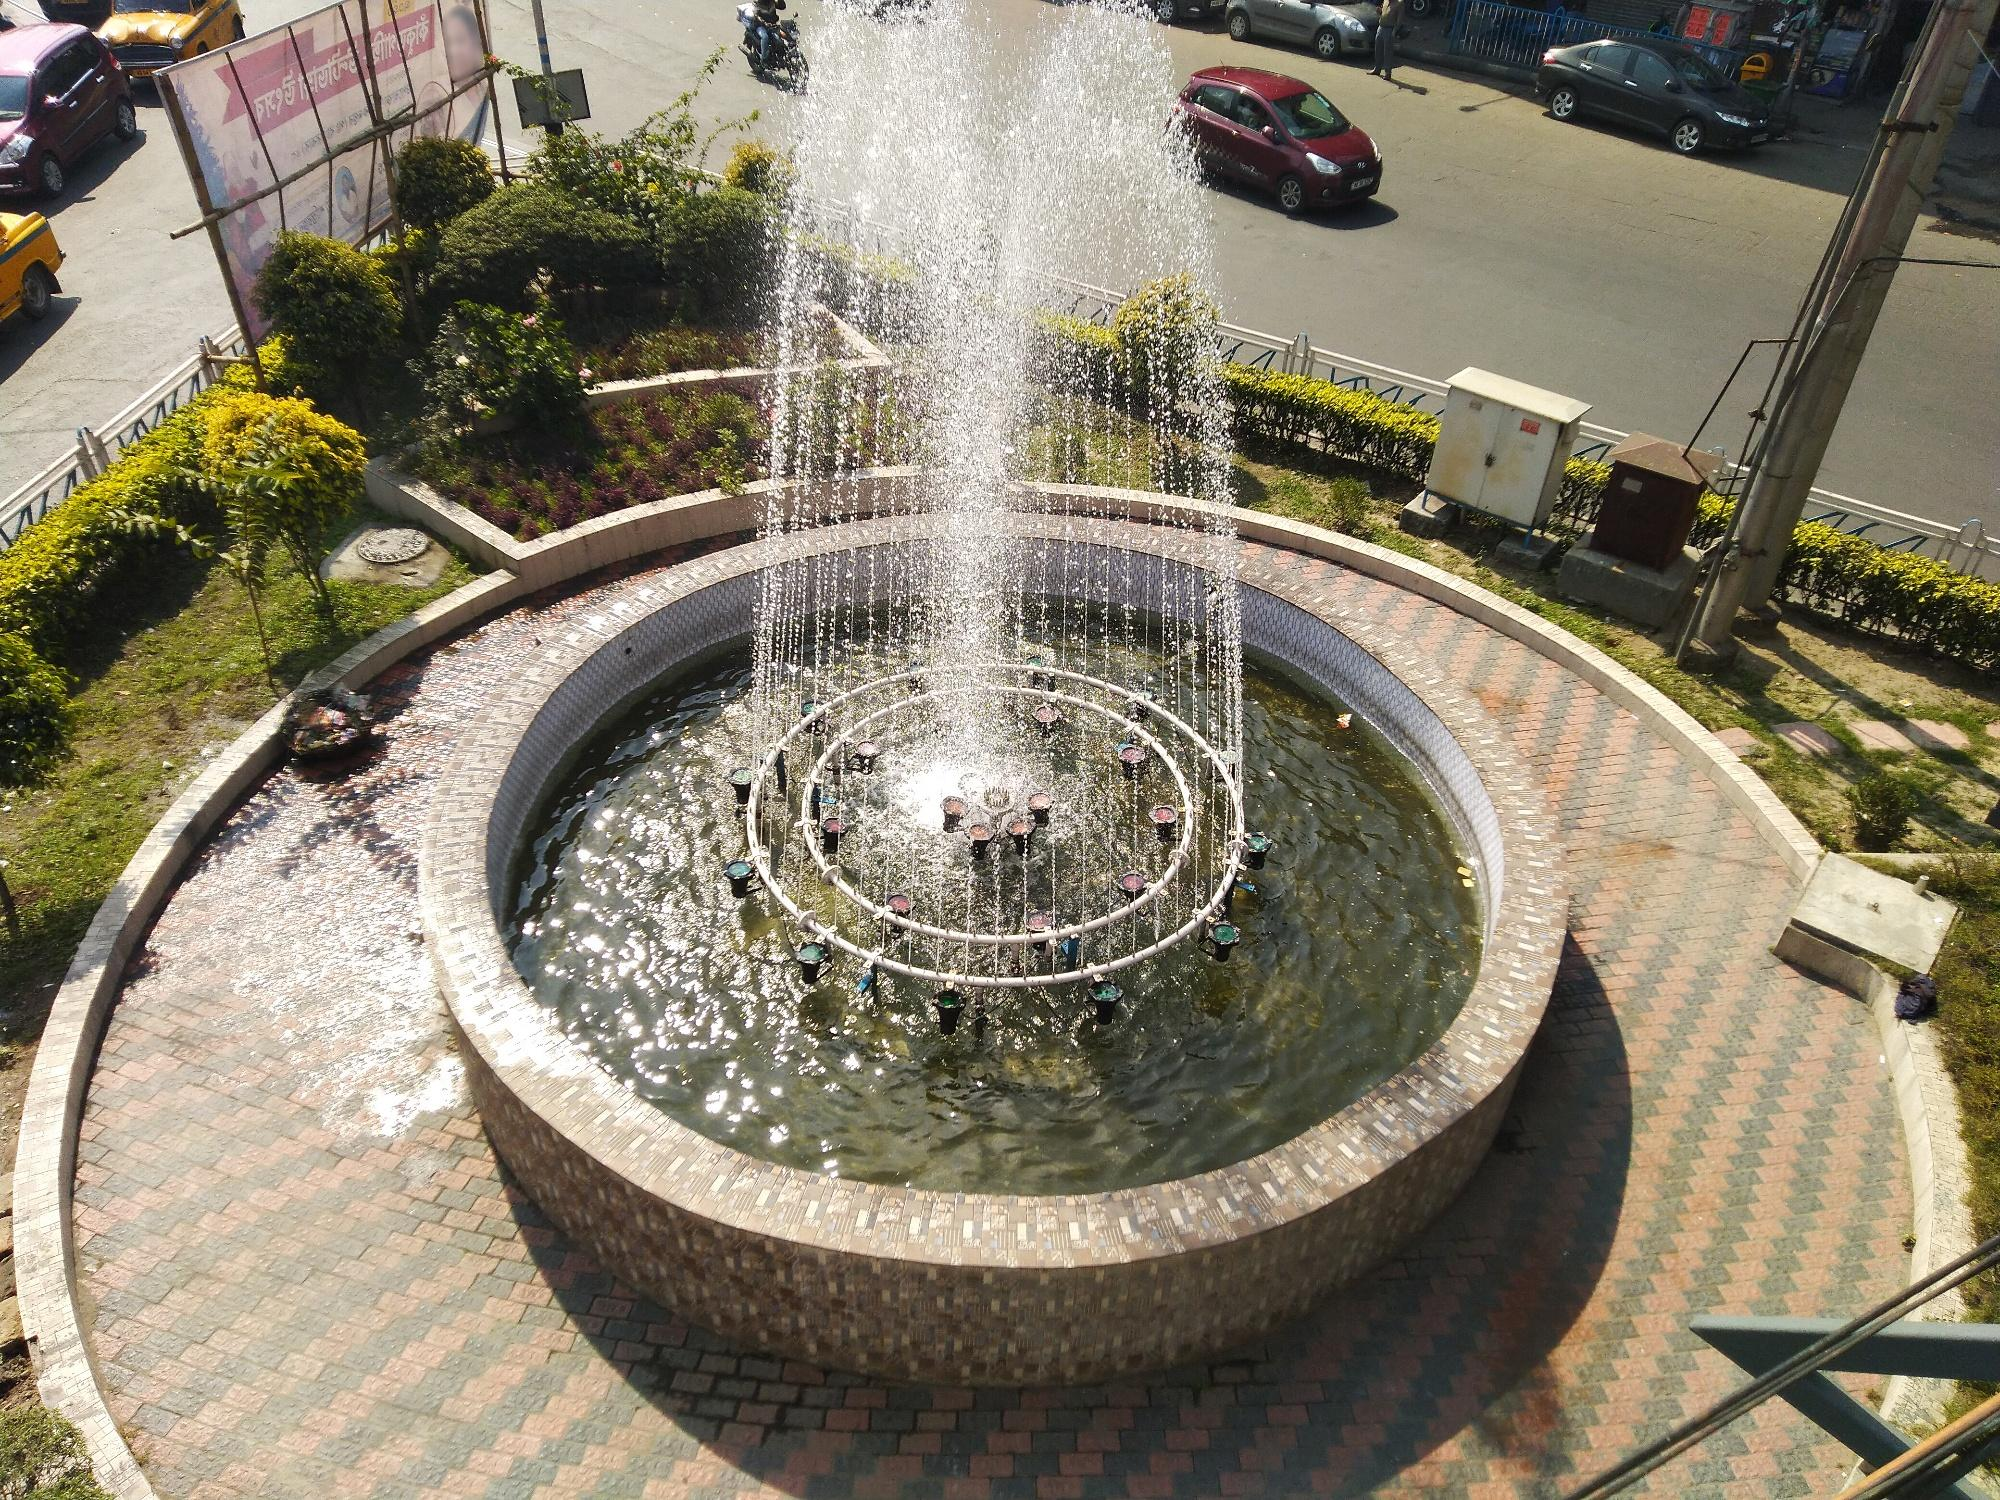Craft a poem about this scene. In the city's heart, where roads entwine,
Lies a fountain, a gem, in design's fine line.
Water dances in the sunlight's embrace,
An urban symphony in an intricate space.

Brick paths encircle where greenery blooms,
A tranquil retreat amidst urban booms.
The busy life swirls around this serene core,
Where nature and structure in harmony soar.

Silent whispers of water, cool mists in the breeze,
Shapes, gracefully arcing, putting minds at ease.
A roundabout of stories, where moments entwine,
In this urban haven, with its timeless shine. 